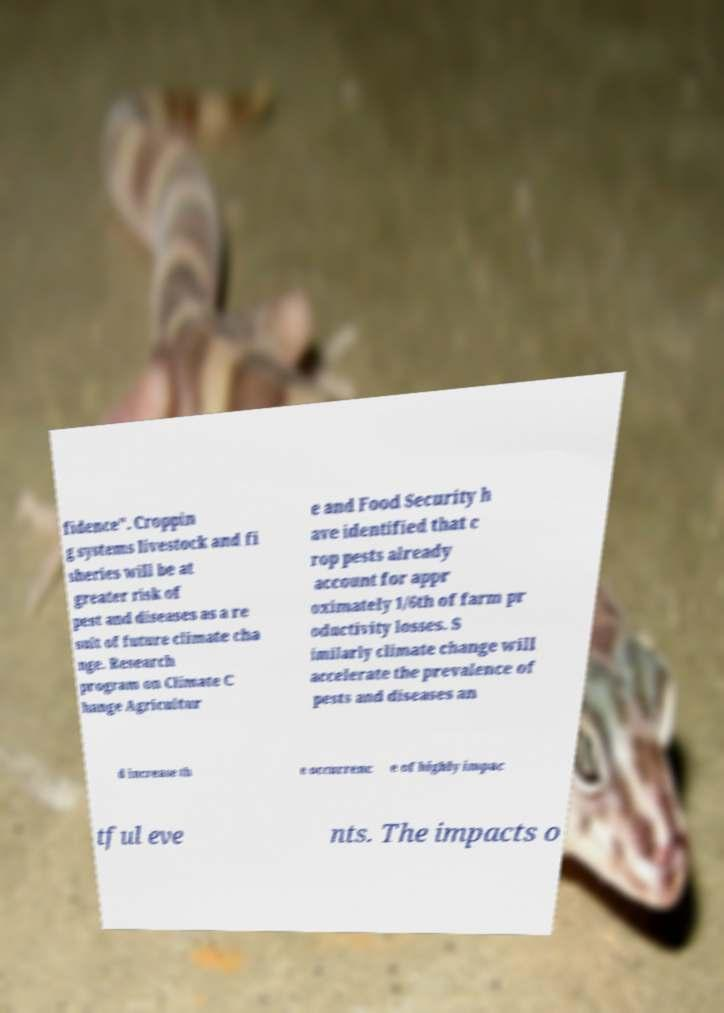For documentation purposes, I need the text within this image transcribed. Could you provide that? fidence". Croppin g systems livestock and fi sheries will be at greater risk of pest and diseases as a re sult of future climate cha nge. Research program on Climate C hange Agricultur e and Food Security h ave identified that c rop pests already account for appr oximately 1/6th of farm pr oductivity losses. S imilarly climate change will accelerate the prevalence of pests and diseases an d increase th e occurrenc e of highly impac tful eve nts. The impacts o 